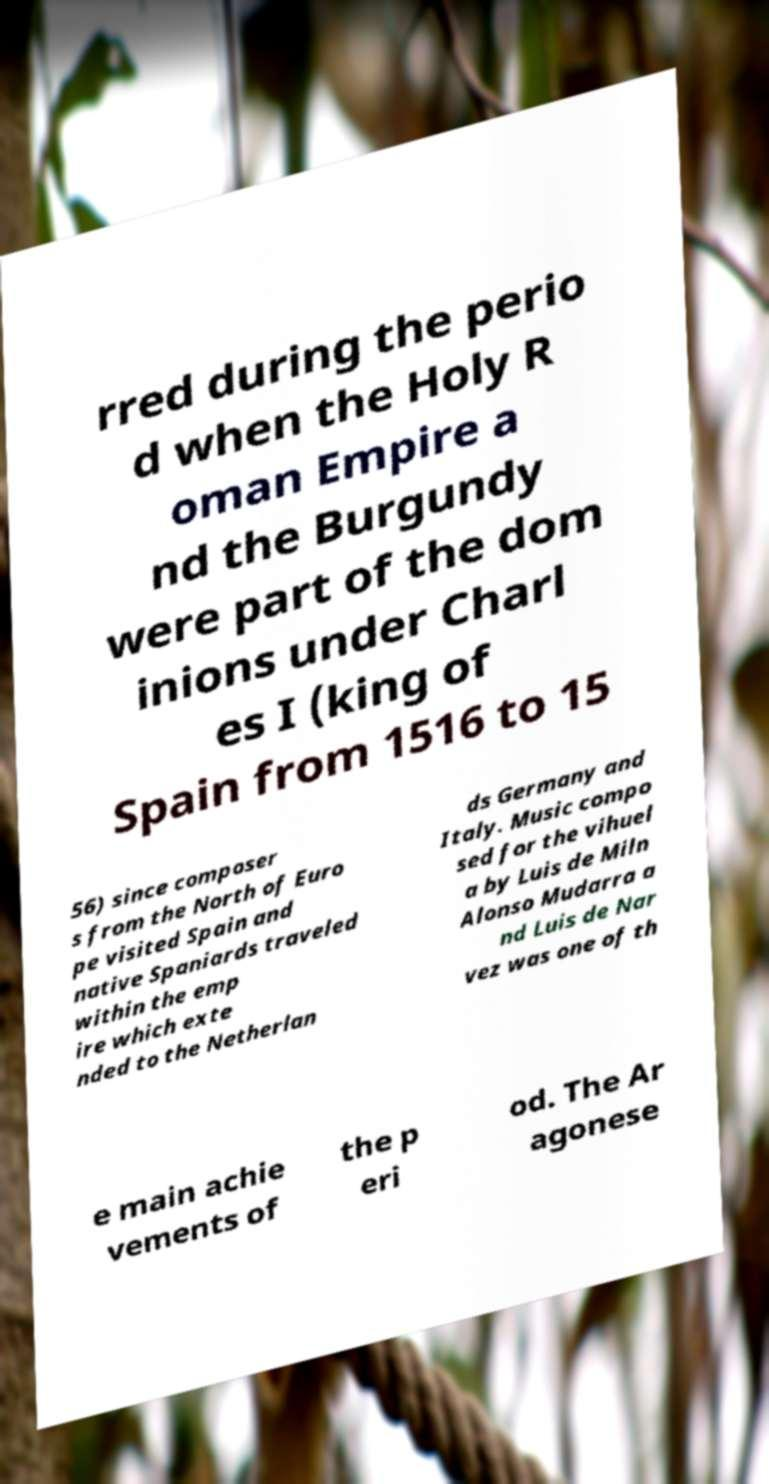Could you assist in decoding the text presented in this image and type it out clearly? rred during the perio d when the Holy R oman Empire a nd the Burgundy were part of the dom inions under Charl es I (king of Spain from 1516 to 15 56) since composer s from the North of Euro pe visited Spain and native Spaniards traveled within the emp ire which exte nded to the Netherlan ds Germany and Italy. Music compo sed for the vihuel a by Luis de Miln Alonso Mudarra a nd Luis de Nar vez was one of th e main achie vements of the p eri od. The Ar agonese 